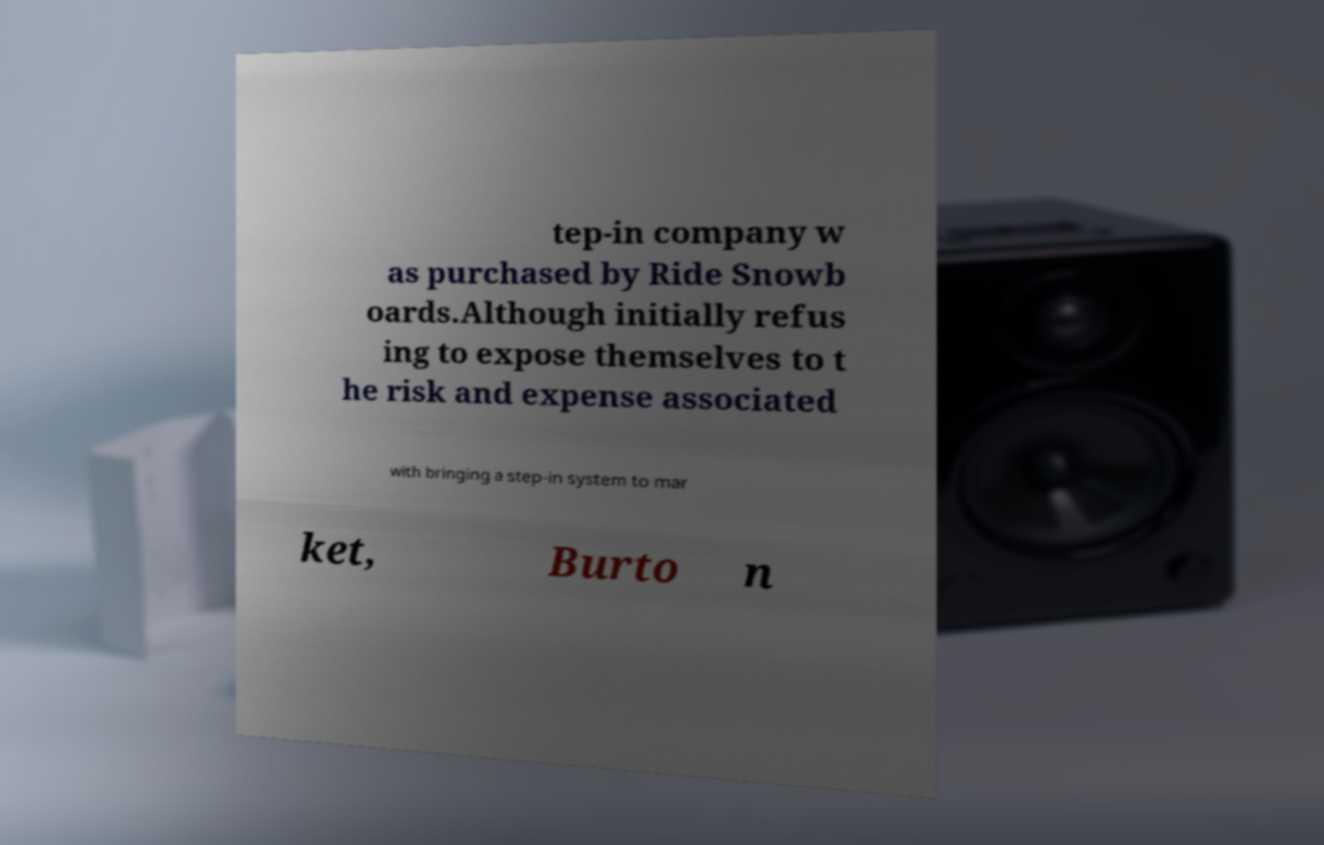What messages or text are displayed in this image? I need them in a readable, typed format. tep-in company w as purchased by Ride Snowb oards.Although initially refus ing to expose themselves to t he risk and expense associated with bringing a step-in system to mar ket, Burto n 